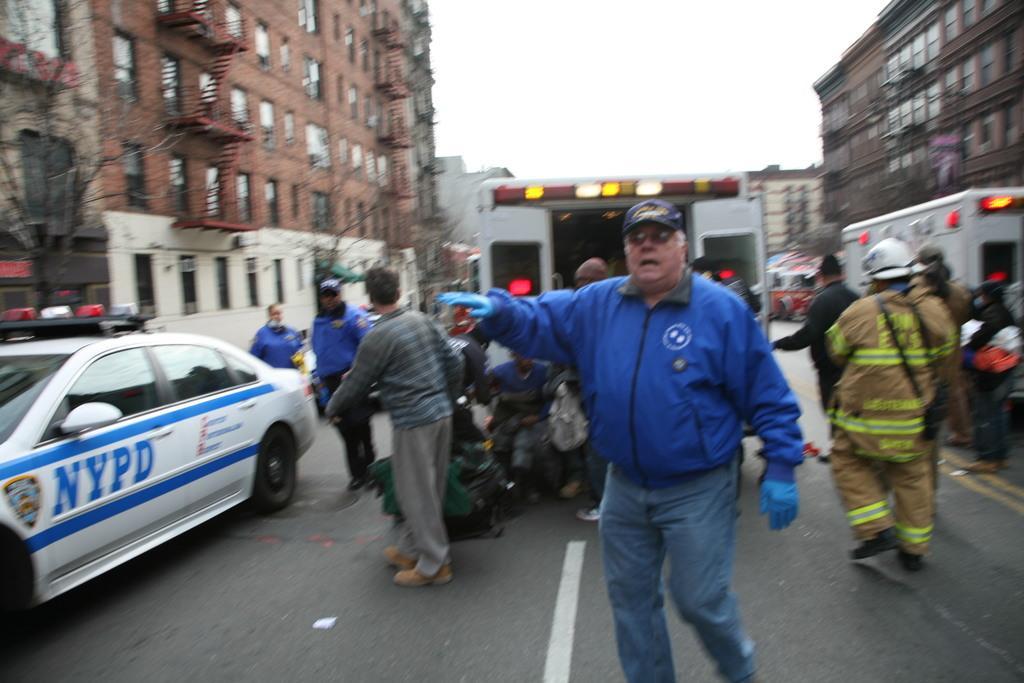Can you describe this image briefly? This picture is clicked outside. In the center we can see the group of persons. On the left there is a white color car seems to be parked on the ground and we can see the text on the car and we can see the two white color vehicles. In the background there is a sky, buildings and we can see the windows of the buildings and some other objects. 